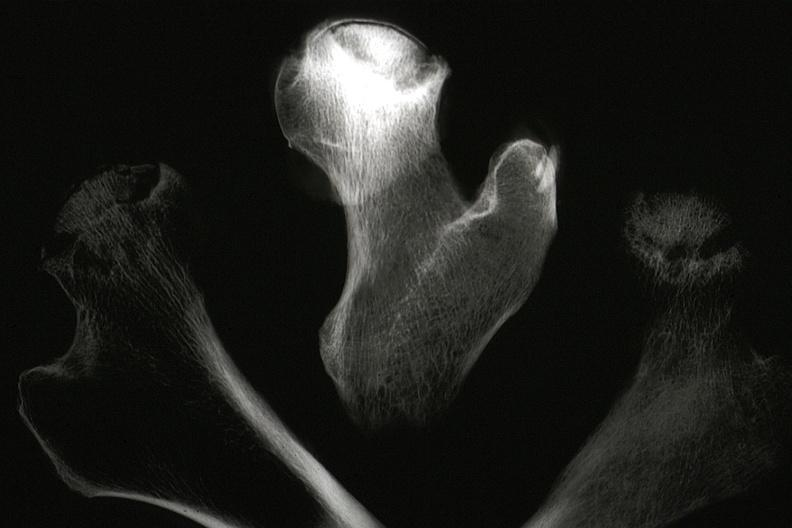how does this image show x-ray of sections of femur?
Answer the question using a single word or phrase. With femoral head necrosis seen in slide 